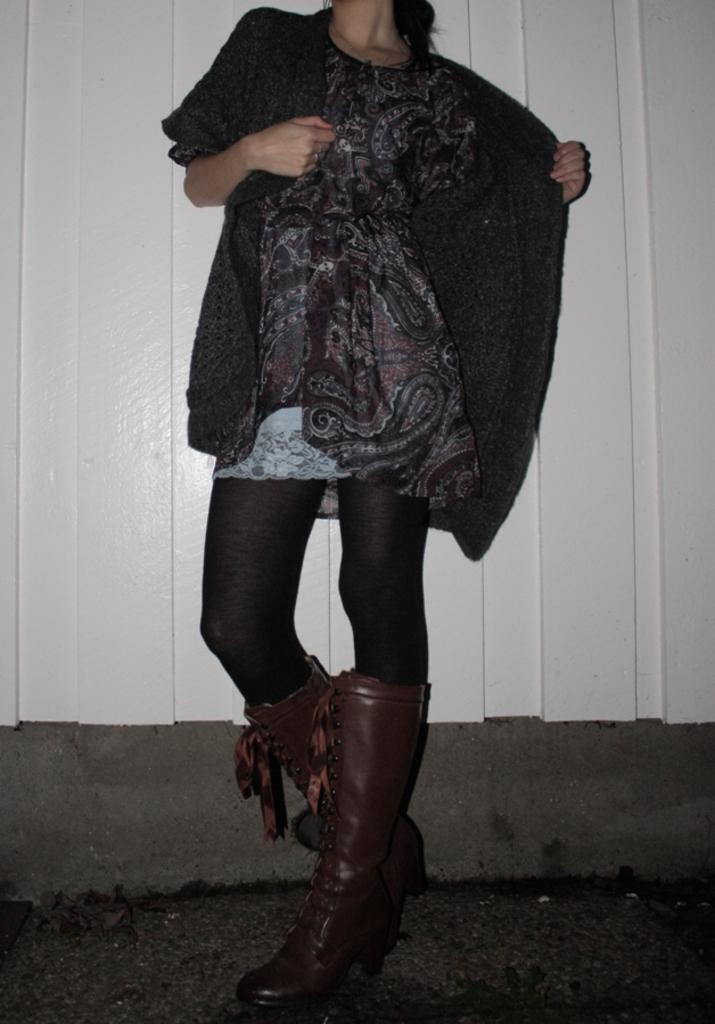Who is the main subject in the image? There is a woman in the image. What is the woman wearing? The woman is wearing a black jacket. Where is the woman standing? The woman is standing on the land. What is the color of the background in the image? The background of the image appears to be white. What type of powder is visible on the woman's elbow in the image? There is no powder visible on the woman's elbow in the image, and her elbow is not mentioned in the provided facts. 